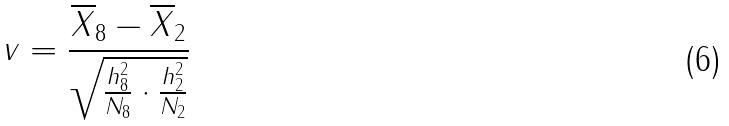Convert formula to latex. <formula><loc_0><loc_0><loc_500><loc_500>v = \frac { \overline { X } _ { 8 } - \overline { X } _ { 2 } } { \sqrt { \frac { h _ { 8 } ^ { 2 } } { N _ { 8 } } \cdot \frac { h _ { 2 } ^ { 2 } } { N _ { 2 } } } }</formula> 